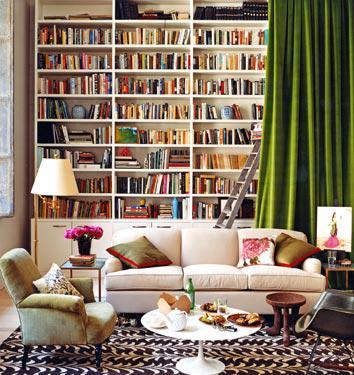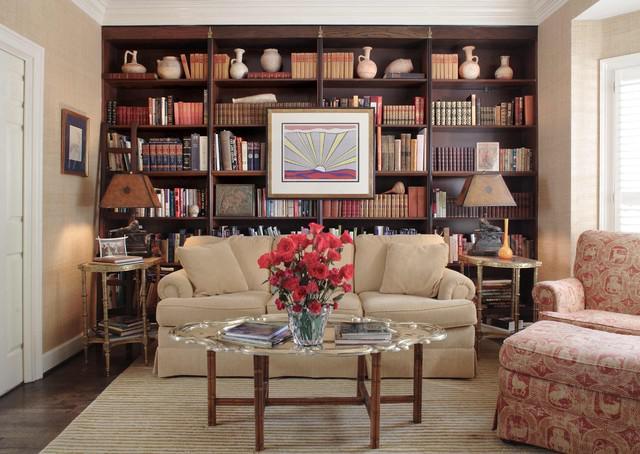The first image is the image on the left, the second image is the image on the right. Analyze the images presented: Is the assertion "An image features a round white table in front of a horizontal couch with assorted pillows, which is in front of a white bookcase." valid? Answer yes or no. Yes. The first image is the image on the left, the second image is the image on the right. Evaluate the accuracy of this statement regarding the images: "One of the tables is small, white, and round.". Is it true? Answer yes or no. Yes. 